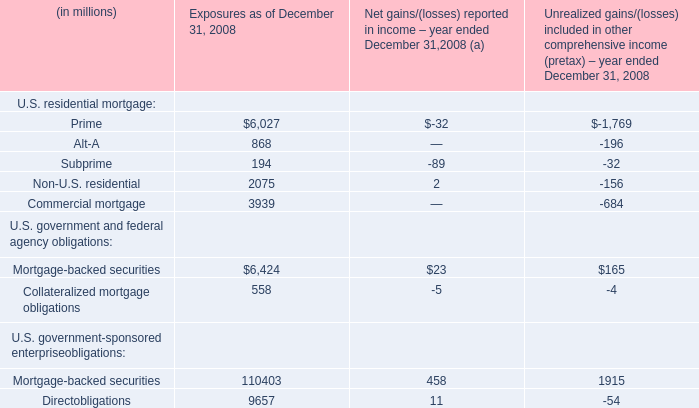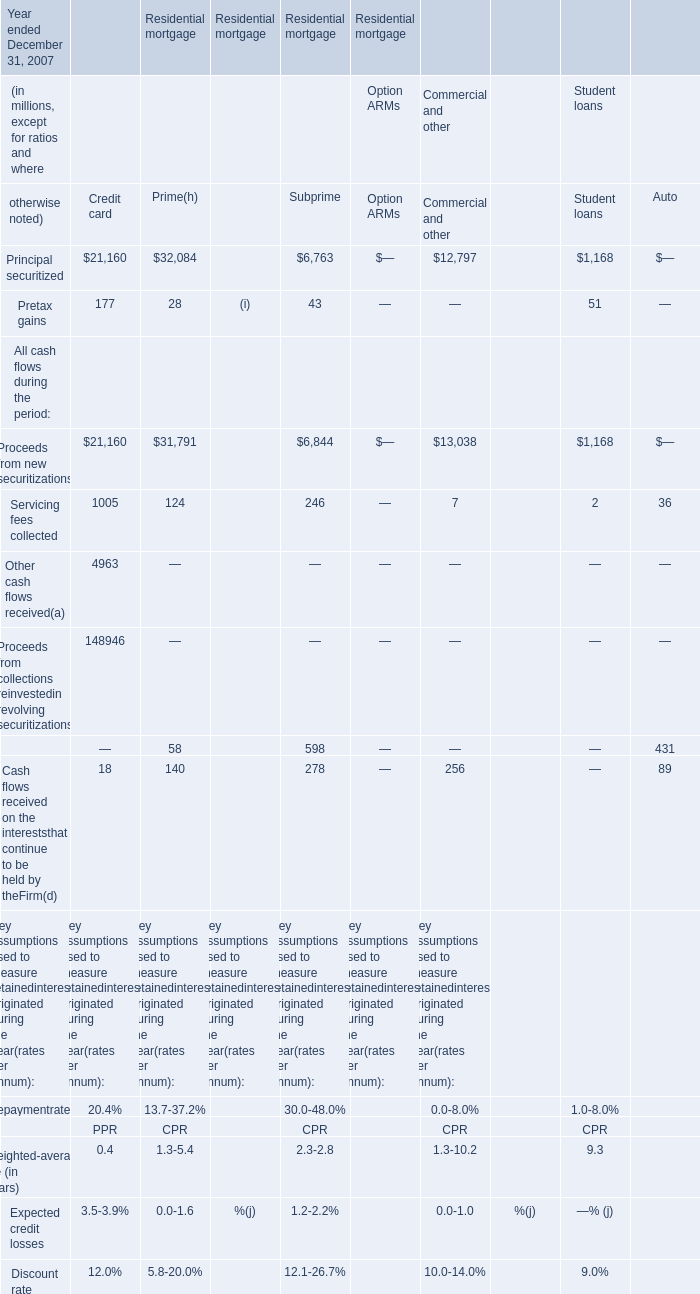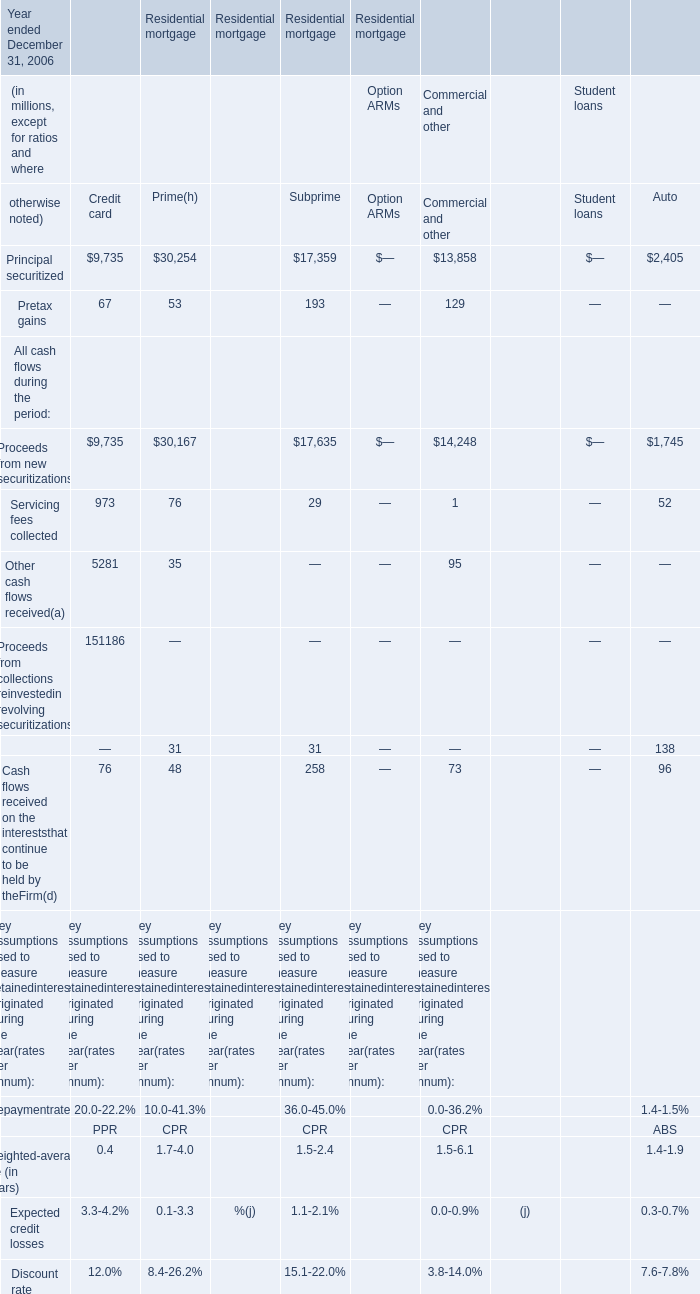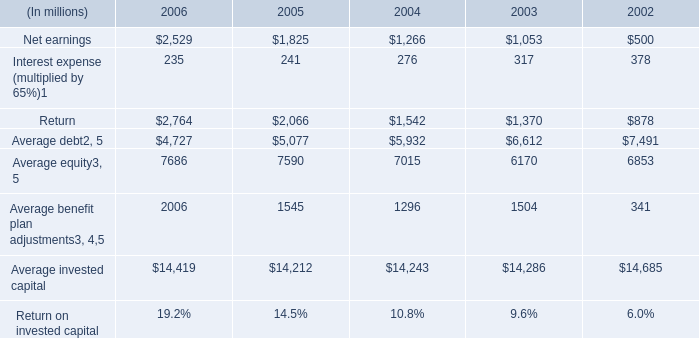What is the average amount of Net earnings of 2006, and Principal securitized of Residential mortgage Credit card ? 
Computations: ((2529.0 + 9735.0) / 2)
Answer: 6132.0. 